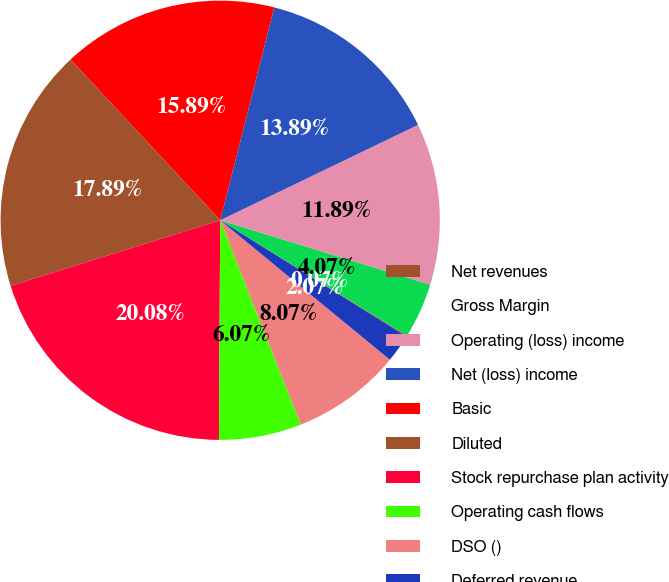Convert chart to OTSL. <chart><loc_0><loc_0><loc_500><loc_500><pie_chart><fcel>Net revenues<fcel>Gross Margin<fcel>Operating (loss) income<fcel>Net (loss) income<fcel>Basic<fcel>Diluted<fcel>Stock repurchase plan activity<fcel>Operating cash flows<fcel>DSO ()<fcel>Deferred revenue<nl><fcel>0.07%<fcel>4.07%<fcel>11.89%<fcel>13.89%<fcel>15.89%<fcel>17.89%<fcel>20.08%<fcel>6.07%<fcel>8.07%<fcel>2.07%<nl></chart> 